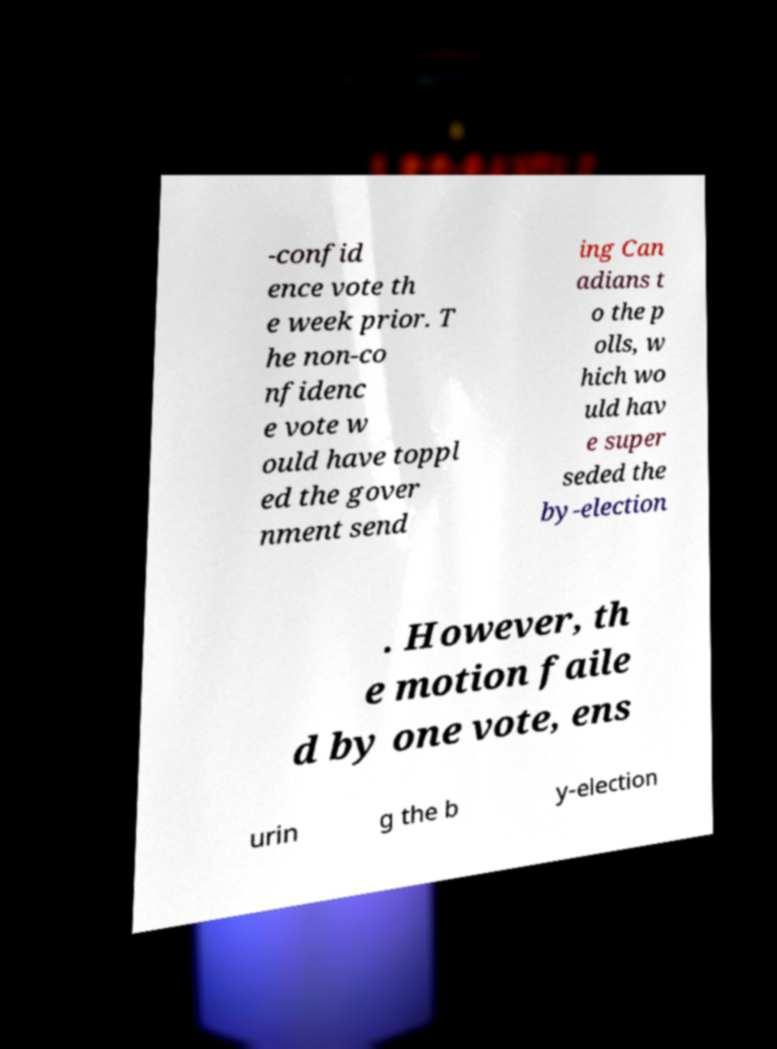I need the written content from this picture converted into text. Can you do that? -confid ence vote th e week prior. T he non-co nfidenc e vote w ould have toppl ed the gover nment send ing Can adians t o the p olls, w hich wo uld hav e super seded the by-election . However, th e motion faile d by one vote, ens urin g the b y-election 